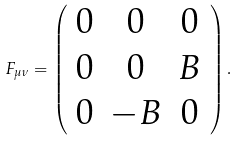Convert formula to latex. <formula><loc_0><loc_0><loc_500><loc_500>F _ { \mu \nu } = \left ( \begin{array} { c c c } 0 & 0 & 0 \\ 0 & 0 & B \\ 0 & - B & 0 \end{array} \right ) .</formula> 